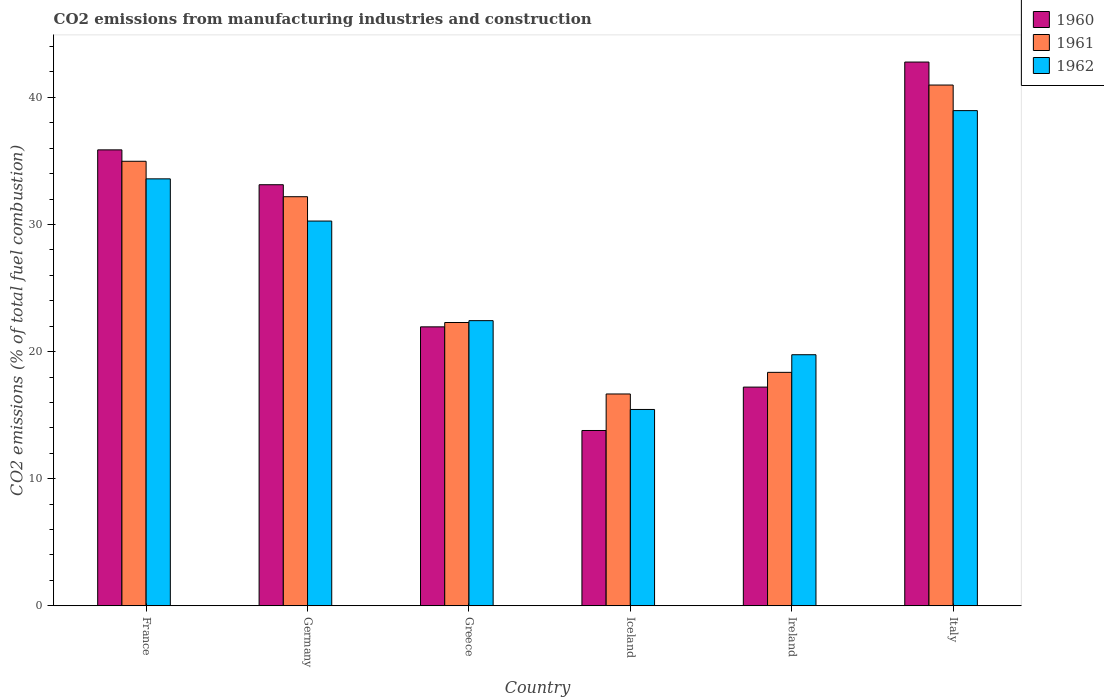How many different coloured bars are there?
Give a very brief answer. 3. How many groups of bars are there?
Your answer should be compact. 6. Are the number of bars per tick equal to the number of legend labels?
Offer a terse response. Yes. How many bars are there on the 4th tick from the right?
Your answer should be very brief. 3. What is the label of the 2nd group of bars from the left?
Your response must be concise. Germany. What is the amount of CO2 emitted in 1962 in Ireland?
Your answer should be very brief. 19.75. Across all countries, what is the maximum amount of CO2 emitted in 1960?
Make the answer very short. 42.78. Across all countries, what is the minimum amount of CO2 emitted in 1962?
Give a very brief answer. 15.45. In which country was the amount of CO2 emitted in 1960 maximum?
Your answer should be very brief. Italy. What is the total amount of CO2 emitted in 1961 in the graph?
Offer a terse response. 165.46. What is the difference between the amount of CO2 emitted in 1962 in Iceland and that in Italy?
Your answer should be very brief. -23.51. What is the difference between the amount of CO2 emitted in 1961 in Italy and the amount of CO2 emitted in 1962 in Ireland?
Your response must be concise. 21.22. What is the average amount of CO2 emitted in 1960 per country?
Your answer should be very brief. 27.46. What is the difference between the amount of CO2 emitted of/in 1961 and amount of CO2 emitted of/in 1960 in Ireland?
Offer a terse response. 1.16. What is the ratio of the amount of CO2 emitted in 1961 in Germany to that in Greece?
Provide a short and direct response. 1.44. What is the difference between the highest and the second highest amount of CO2 emitted in 1962?
Your response must be concise. -5.37. What is the difference between the highest and the lowest amount of CO2 emitted in 1962?
Offer a terse response. 23.51. In how many countries, is the amount of CO2 emitted in 1960 greater than the average amount of CO2 emitted in 1960 taken over all countries?
Offer a terse response. 3. What does the 1st bar from the right in Iceland represents?
Offer a terse response. 1962. Are all the bars in the graph horizontal?
Offer a very short reply. No. How many countries are there in the graph?
Make the answer very short. 6. What is the difference between two consecutive major ticks on the Y-axis?
Your answer should be compact. 10. Does the graph contain any zero values?
Offer a very short reply. No. How many legend labels are there?
Ensure brevity in your answer.  3. What is the title of the graph?
Give a very brief answer. CO2 emissions from manufacturing industries and construction. Does "1985" appear as one of the legend labels in the graph?
Provide a succinct answer. No. What is the label or title of the Y-axis?
Your answer should be very brief. CO2 emissions (% of total fuel combustion). What is the CO2 emissions (% of total fuel combustion) of 1960 in France?
Provide a short and direct response. 35.87. What is the CO2 emissions (% of total fuel combustion) in 1961 in France?
Your answer should be very brief. 34.98. What is the CO2 emissions (% of total fuel combustion) in 1962 in France?
Offer a very short reply. 33.59. What is the CO2 emissions (% of total fuel combustion) in 1960 in Germany?
Provide a succinct answer. 33.13. What is the CO2 emissions (% of total fuel combustion) of 1961 in Germany?
Keep it short and to the point. 32.19. What is the CO2 emissions (% of total fuel combustion) in 1962 in Germany?
Keep it short and to the point. 30.27. What is the CO2 emissions (% of total fuel combustion) in 1960 in Greece?
Keep it short and to the point. 21.95. What is the CO2 emissions (% of total fuel combustion) of 1961 in Greece?
Provide a succinct answer. 22.29. What is the CO2 emissions (% of total fuel combustion) of 1962 in Greece?
Keep it short and to the point. 22.44. What is the CO2 emissions (% of total fuel combustion) of 1960 in Iceland?
Provide a short and direct response. 13.79. What is the CO2 emissions (% of total fuel combustion) of 1961 in Iceland?
Provide a short and direct response. 16.67. What is the CO2 emissions (% of total fuel combustion) of 1962 in Iceland?
Ensure brevity in your answer.  15.45. What is the CO2 emissions (% of total fuel combustion) of 1960 in Ireland?
Make the answer very short. 17.21. What is the CO2 emissions (% of total fuel combustion) of 1961 in Ireland?
Make the answer very short. 18.37. What is the CO2 emissions (% of total fuel combustion) of 1962 in Ireland?
Offer a very short reply. 19.75. What is the CO2 emissions (% of total fuel combustion) in 1960 in Italy?
Ensure brevity in your answer.  42.78. What is the CO2 emissions (% of total fuel combustion) of 1961 in Italy?
Keep it short and to the point. 40.97. What is the CO2 emissions (% of total fuel combustion) in 1962 in Italy?
Offer a very short reply. 38.96. Across all countries, what is the maximum CO2 emissions (% of total fuel combustion) in 1960?
Make the answer very short. 42.78. Across all countries, what is the maximum CO2 emissions (% of total fuel combustion) of 1961?
Give a very brief answer. 40.97. Across all countries, what is the maximum CO2 emissions (% of total fuel combustion) in 1962?
Provide a short and direct response. 38.96. Across all countries, what is the minimum CO2 emissions (% of total fuel combustion) of 1960?
Your answer should be compact. 13.79. Across all countries, what is the minimum CO2 emissions (% of total fuel combustion) of 1961?
Provide a short and direct response. 16.67. Across all countries, what is the minimum CO2 emissions (% of total fuel combustion) of 1962?
Make the answer very short. 15.45. What is the total CO2 emissions (% of total fuel combustion) in 1960 in the graph?
Give a very brief answer. 164.73. What is the total CO2 emissions (% of total fuel combustion) of 1961 in the graph?
Provide a short and direct response. 165.46. What is the total CO2 emissions (% of total fuel combustion) in 1962 in the graph?
Provide a succinct answer. 160.46. What is the difference between the CO2 emissions (% of total fuel combustion) in 1960 in France and that in Germany?
Offer a very short reply. 2.74. What is the difference between the CO2 emissions (% of total fuel combustion) of 1961 in France and that in Germany?
Your answer should be very brief. 2.79. What is the difference between the CO2 emissions (% of total fuel combustion) in 1962 in France and that in Germany?
Your answer should be very brief. 3.32. What is the difference between the CO2 emissions (% of total fuel combustion) of 1960 in France and that in Greece?
Your response must be concise. 13.92. What is the difference between the CO2 emissions (% of total fuel combustion) in 1961 in France and that in Greece?
Your answer should be very brief. 12.69. What is the difference between the CO2 emissions (% of total fuel combustion) of 1962 in France and that in Greece?
Your answer should be compact. 11.16. What is the difference between the CO2 emissions (% of total fuel combustion) of 1960 in France and that in Iceland?
Make the answer very short. 22.08. What is the difference between the CO2 emissions (% of total fuel combustion) in 1961 in France and that in Iceland?
Make the answer very short. 18.31. What is the difference between the CO2 emissions (% of total fuel combustion) of 1962 in France and that in Iceland?
Offer a terse response. 18.14. What is the difference between the CO2 emissions (% of total fuel combustion) in 1960 in France and that in Ireland?
Offer a very short reply. 18.67. What is the difference between the CO2 emissions (% of total fuel combustion) of 1961 in France and that in Ireland?
Your answer should be very brief. 16.61. What is the difference between the CO2 emissions (% of total fuel combustion) of 1962 in France and that in Ireland?
Offer a very short reply. 13.84. What is the difference between the CO2 emissions (% of total fuel combustion) of 1960 in France and that in Italy?
Offer a terse response. -6.91. What is the difference between the CO2 emissions (% of total fuel combustion) in 1961 in France and that in Italy?
Offer a terse response. -6. What is the difference between the CO2 emissions (% of total fuel combustion) in 1962 in France and that in Italy?
Your answer should be compact. -5.37. What is the difference between the CO2 emissions (% of total fuel combustion) in 1960 in Germany and that in Greece?
Keep it short and to the point. 11.18. What is the difference between the CO2 emissions (% of total fuel combustion) of 1961 in Germany and that in Greece?
Give a very brief answer. 9.9. What is the difference between the CO2 emissions (% of total fuel combustion) of 1962 in Germany and that in Greece?
Make the answer very short. 7.84. What is the difference between the CO2 emissions (% of total fuel combustion) in 1960 in Germany and that in Iceland?
Your response must be concise. 19.34. What is the difference between the CO2 emissions (% of total fuel combustion) of 1961 in Germany and that in Iceland?
Your answer should be compact. 15.52. What is the difference between the CO2 emissions (% of total fuel combustion) of 1962 in Germany and that in Iceland?
Your response must be concise. 14.82. What is the difference between the CO2 emissions (% of total fuel combustion) in 1960 in Germany and that in Ireland?
Provide a succinct answer. 15.92. What is the difference between the CO2 emissions (% of total fuel combustion) in 1961 in Germany and that in Ireland?
Your response must be concise. 13.82. What is the difference between the CO2 emissions (% of total fuel combustion) in 1962 in Germany and that in Ireland?
Keep it short and to the point. 10.52. What is the difference between the CO2 emissions (% of total fuel combustion) in 1960 in Germany and that in Italy?
Your answer should be compact. -9.65. What is the difference between the CO2 emissions (% of total fuel combustion) of 1961 in Germany and that in Italy?
Your answer should be very brief. -8.79. What is the difference between the CO2 emissions (% of total fuel combustion) of 1962 in Germany and that in Italy?
Provide a succinct answer. -8.69. What is the difference between the CO2 emissions (% of total fuel combustion) in 1960 in Greece and that in Iceland?
Your response must be concise. 8.15. What is the difference between the CO2 emissions (% of total fuel combustion) of 1961 in Greece and that in Iceland?
Make the answer very short. 5.62. What is the difference between the CO2 emissions (% of total fuel combustion) of 1962 in Greece and that in Iceland?
Your response must be concise. 6.99. What is the difference between the CO2 emissions (% of total fuel combustion) in 1960 in Greece and that in Ireland?
Offer a terse response. 4.74. What is the difference between the CO2 emissions (% of total fuel combustion) in 1961 in Greece and that in Ireland?
Offer a terse response. 3.92. What is the difference between the CO2 emissions (% of total fuel combustion) of 1962 in Greece and that in Ireland?
Your answer should be very brief. 2.68. What is the difference between the CO2 emissions (% of total fuel combustion) in 1960 in Greece and that in Italy?
Give a very brief answer. -20.83. What is the difference between the CO2 emissions (% of total fuel combustion) of 1961 in Greece and that in Italy?
Ensure brevity in your answer.  -18.68. What is the difference between the CO2 emissions (% of total fuel combustion) of 1962 in Greece and that in Italy?
Offer a very short reply. -16.53. What is the difference between the CO2 emissions (% of total fuel combustion) of 1960 in Iceland and that in Ireland?
Make the answer very short. -3.41. What is the difference between the CO2 emissions (% of total fuel combustion) of 1961 in Iceland and that in Ireland?
Ensure brevity in your answer.  -1.7. What is the difference between the CO2 emissions (% of total fuel combustion) of 1962 in Iceland and that in Ireland?
Give a very brief answer. -4.31. What is the difference between the CO2 emissions (% of total fuel combustion) of 1960 in Iceland and that in Italy?
Offer a terse response. -28.99. What is the difference between the CO2 emissions (% of total fuel combustion) in 1961 in Iceland and that in Italy?
Offer a very short reply. -24.31. What is the difference between the CO2 emissions (% of total fuel combustion) of 1962 in Iceland and that in Italy?
Give a very brief answer. -23.51. What is the difference between the CO2 emissions (% of total fuel combustion) in 1960 in Ireland and that in Italy?
Offer a terse response. -25.57. What is the difference between the CO2 emissions (% of total fuel combustion) in 1961 in Ireland and that in Italy?
Ensure brevity in your answer.  -22.61. What is the difference between the CO2 emissions (% of total fuel combustion) of 1962 in Ireland and that in Italy?
Offer a very short reply. -19.21. What is the difference between the CO2 emissions (% of total fuel combustion) of 1960 in France and the CO2 emissions (% of total fuel combustion) of 1961 in Germany?
Make the answer very short. 3.68. What is the difference between the CO2 emissions (% of total fuel combustion) in 1960 in France and the CO2 emissions (% of total fuel combustion) in 1962 in Germany?
Make the answer very short. 5.6. What is the difference between the CO2 emissions (% of total fuel combustion) in 1961 in France and the CO2 emissions (% of total fuel combustion) in 1962 in Germany?
Make the answer very short. 4.7. What is the difference between the CO2 emissions (% of total fuel combustion) in 1960 in France and the CO2 emissions (% of total fuel combustion) in 1961 in Greece?
Offer a terse response. 13.58. What is the difference between the CO2 emissions (% of total fuel combustion) in 1960 in France and the CO2 emissions (% of total fuel combustion) in 1962 in Greece?
Your answer should be very brief. 13.44. What is the difference between the CO2 emissions (% of total fuel combustion) in 1961 in France and the CO2 emissions (% of total fuel combustion) in 1962 in Greece?
Keep it short and to the point. 12.54. What is the difference between the CO2 emissions (% of total fuel combustion) of 1960 in France and the CO2 emissions (% of total fuel combustion) of 1961 in Iceland?
Keep it short and to the point. 19.21. What is the difference between the CO2 emissions (% of total fuel combustion) in 1960 in France and the CO2 emissions (% of total fuel combustion) in 1962 in Iceland?
Your answer should be compact. 20.43. What is the difference between the CO2 emissions (% of total fuel combustion) of 1961 in France and the CO2 emissions (% of total fuel combustion) of 1962 in Iceland?
Provide a short and direct response. 19.53. What is the difference between the CO2 emissions (% of total fuel combustion) of 1960 in France and the CO2 emissions (% of total fuel combustion) of 1961 in Ireland?
Offer a terse response. 17.51. What is the difference between the CO2 emissions (% of total fuel combustion) of 1960 in France and the CO2 emissions (% of total fuel combustion) of 1962 in Ireland?
Ensure brevity in your answer.  16.12. What is the difference between the CO2 emissions (% of total fuel combustion) in 1961 in France and the CO2 emissions (% of total fuel combustion) in 1962 in Ireland?
Provide a short and direct response. 15.22. What is the difference between the CO2 emissions (% of total fuel combustion) of 1960 in France and the CO2 emissions (% of total fuel combustion) of 1961 in Italy?
Your answer should be compact. -5.1. What is the difference between the CO2 emissions (% of total fuel combustion) in 1960 in France and the CO2 emissions (% of total fuel combustion) in 1962 in Italy?
Your answer should be very brief. -3.09. What is the difference between the CO2 emissions (% of total fuel combustion) in 1961 in France and the CO2 emissions (% of total fuel combustion) in 1962 in Italy?
Your answer should be compact. -3.99. What is the difference between the CO2 emissions (% of total fuel combustion) in 1960 in Germany and the CO2 emissions (% of total fuel combustion) in 1961 in Greece?
Make the answer very short. 10.84. What is the difference between the CO2 emissions (% of total fuel combustion) in 1960 in Germany and the CO2 emissions (% of total fuel combustion) in 1962 in Greece?
Provide a succinct answer. 10.69. What is the difference between the CO2 emissions (% of total fuel combustion) in 1961 in Germany and the CO2 emissions (% of total fuel combustion) in 1962 in Greece?
Provide a succinct answer. 9.75. What is the difference between the CO2 emissions (% of total fuel combustion) in 1960 in Germany and the CO2 emissions (% of total fuel combustion) in 1961 in Iceland?
Make the answer very short. 16.46. What is the difference between the CO2 emissions (% of total fuel combustion) of 1960 in Germany and the CO2 emissions (% of total fuel combustion) of 1962 in Iceland?
Offer a very short reply. 17.68. What is the difference between the CO2 emissions (% of total fuel combustion) in 1961 in Germany and the CO2 emissions (% of total fuel combustion) in 1962 in Iceland?
Provide a succinct answer. 16.74. What is the difference between the CO2 emissions (% of total fuel combustion) of 1960 in Germany and the CO2 emissions (% of total fuel combustion) of 1961 in Ireland?
Your answer should be compact. 14.76. What is the difference between the CO2 emissions (% of total fuel combustion) of 1960 in Germany and the CO2 emissions (% of total fuel combustion) of 1962 in Ireland?
Your response must be concise. 13.38. What is the difference between the CO2 emissions (% of total fuel combustion) in 1961 in Germany and the CO2 emissions (% of total fuel combustion) in 1962 in Ireland?
Ensure brevity in your answer.  12.43. What is the difference between the CO2 emissions (% of total fuel combustion) in 1960 in Germany and the CO2 emissions (% of total fuel combustion) in 1961 in Italy?
Offer a very short reply. -7.84. What is the difference between the CO2 emissions (% of total fuel combustion) in 1960 in Germany and the CO2 emissions (% of total fuel combustion) in 1962 in Italy?
Offer a very short reply. -5.83. What is the difference between the CO2 emissions (% of total fuel combustion) in 1961 in Germany and the CO2 emissions (% of total fuel combustion) in 1962 in Italy?
Provide a succinct answer. -6.77. What is the difference between the CO2 emissions (% of total fuel combustion) in 1960 in Greece and the CO2 emissions (% of total fuel combustion) in 1961 in Iceland?
Provide a succinct answer. 5.28. What is the difference between the CO2 emissions (% of total fuel combustion) of 1960 in Greece and the CO2 emissions (% of total fuel combustion) of 1962 in Iceland?
Provide a succinct answer. 6.5. What is the difference between the CO2 emissions (% of total fuel combustion) in 1961 in Greece and the CO2 emissions (% of total fuel combustion) in 1962 in Iceland?
Offer a terse response. 6.84. What is the difference between the CO2 emissions (% of total fuel combustion) of 1960 in Greece and the CO2 emissions (% of total fuel combustion) of 1961 in Ireland?
Make the answer very short. 3.58. What is the difference between the CO2 emissions (% of total fuel combustion) in 1960 in Greece and the CO2 emissions (% of total fuel combustion) in 1962 in Ireland?
Offer a very short reply. 2.19. What is the difference between the CO2 emissions (% of total fuel combustion) in 1961 in Greece and the CO2 emissions (% of total fuel combustion) in 1962 in Ireland?
Ensure brevity in your answer.  2.54. What is the difference between the CO2 emissions (% of total fuel combustion) in 1960 in Greece and the CO2 emissions (% of total fuel combustion) in 1961 in Italy?
Your answer should be very brief. -19.03. What is the difference between the CO2 emissions (% of total fuel combustion) in 1960 in Greece and the CO2 emissions (% of total fuel combustion) in 1962 in Italy?
Provide a succinct answer. -17.01. What is the difference between the CO2 emissions (% of total fuel combustion) in 1961 in Greece and the CO2 emissions (% of total fuel combustion) in 1962 in Italy?
Provide a succinct answer. -16.67. What is the difference between the CO2 emissions (% of total fuel combustion) of 1960 in Iceland and the CO2 emissions (% of total fuel combustion) of 1961 in Ireland?
Provide a short and direct response. -4.57. What is the difference between the CO2 emissions (% of total fuel combustion) in 1960 in Iceland and the CO2 emissions (% of total fuel combustion) in 1962 in Ireland?
Your answer should be very brief. -5.96. What is the difference between the CO2 emissions (% of total fuel combustion) of 1961 in Iceland and the CO2 emissions (% of total fuel combustion) of 1962 in Ireland?
Your response must be concise. -3.09. What is the difference between the CO2 emissions (% of total fuel combustion) in 1960 in Iceland and the CO2 emissions (% of total fuel combustion) in 1961 in Italy?
Provide a short and direct response. -27.18. What is the difference between the CO2 emissions (% of total fuel combustion) of 1960 in Iceland and the CO2 emissions (% of total fuel combustion) of 1962 in Italy?
Provide a short and direct response. -25.17. What is the difference between the CO2 emissions (% of total fuel combustion) in 1961 in Iceland and the CO2 emissions (% of total fuel combustion) in 1962 in Italy?
Your response must be concise. -22.29. What is the difference between the CO2 emissions (% of total fuel combustion) in 1960 in Ireland and the CO2 emissions (% of total fuel combustion) in 1961 in Italy?
Your response must be concise. -23.77. What is the difference between the CO2 emissions (% of total fuel combustion) of 1960 in Ireland and the CO2 emissions (% of total fuel combustion) of 1962 in Italy?
Make the answer very short. -21.75. What is the difference between the CO2 emissions (% of total fuel combustion) in 1961 in Ireland and the CO2 emissions (% of total fuel combustion) in 1962 in Italy?
Your response must be concise. -20.59. What is the average CO2 emissions (% of total fuel combustion) of 1960 per country?
Your response must be concise. 27.46. What is the average CO2 emissions (% of total fuel combustion) in 1961 per country?
Your response must be concise. 27.58. What is the average CO2 emissions (% of total fuel combustion) in 1962 per country?
Make the answer very short. 26.74. What is the difference between the CO2 emissions (% of total fuel combustion) in 1960 and CO2 emissions (% of total fuel combustion) in 1961 in France?
Offer a very short reply. 0.9. What is the difference between the CO2 emissions (% of total fuel combustion) in 1960 and CO2 emissions (% of total fuel combustion) in 1962 in France?
Ensure brevity in your answer.  2.28. What is the difference between the CO2 emissions (% of total fuel combustion) of 1961 and CO2 emissions (% of total fuel combustion) of 1962 in France?
Your response must be concise. 1.38. What is the difference between the CO2 emissions (% of total fuel combustion) in 1960 and CO2 emissions (% of total fuel combustion) in 1961 in Germany?
Ensure brevity in your answer.  0.94. What is the difference between the CO2 emissions (% of total fuel combustion) in 1960 and CO2 emissions (% of total fuel combustion) in 1962 in Germany?
Offer a terse response. 2.86. What is the difference between the CO2 emissions (% of total fuel combustion) in 1961 and CO2 emissions (% of total fuel combustion) in 1962 in Germany?
Ensure brevity in your answer.  1.92. What is the difference between the CO2 emissions (% of total fuel combustion) in 1960 and CO2 emissions (% of total fuel combustion) in 1961 in Greece?
Provide a succinct answer. -0.34. What is the difference between the CO2 emissions (% of total fuel combustion) of 1960 and CO2 emissions (% of total fuel combustion) of 1962 in Greece?
Provide a short and direct response. -0.49. What is the difference between the CO2 emissions (% of total fuel combustion) of 1961 and CO2 emissions (% of total fuel combustion) of 1962 in Greece?
Offer a terse response. -0.15. What is the difference between the CO2 emissions (% of total fuel combustion) in 1960 and CO2 emissions (% of total fuel combustion) in 1961 in Iceland?
Keep it short and to the point. -2.87. What is the difference between the CO2 emissions (% of total fuel combustion) in 1960 and CO2 emissions (% of total fuel combustion) in 1962 in Iceland?
Offer a very short reply. -1.65. What is the difference between the CO2 emissions (% of total fuel combustion) of 1961 and CO2 emissions (% of total fuel combustion) of 1962 in Iceland?
Give a very brief answer. 1.22. What is the difference between the CO2 emissions (% of total fuel combustion) in 1960 and CO2 emissions (% of total fuel combustion) in 1961 in Ireland?
Your response must be concise. -1.16. What is the difference between the CO2 emissions (% of total fuel combustion) in 1960 and CO2 emissions (% of total fuel combustion) in 1962 in Ireland?
Provide a short and direct response. -2.55. What is the difference between the CO2 emissions (% of total fuel combustion) in 1961 and CO2 emissions (% of total fuel combustion) in 1962 in Ireland?
Make the answer very short. -1.39. What is the difference between the CO2 emissions (% of total fuel combustion) in 1960 and CO2 emissions (% of total fuel combustion) in 1961 in Italy?
Provide a succinct answer. 1.81. What is the difference between the CO2 emissions (% of total fuel combustion) of 1960 and CO2 emissions (% of total fuel combustion) of 1962 in Italy?
Provide a short and direct response. 3.82. What is the difference between the CO2 emissions (% of total fuel combustion) of 1961 and CO2 emissions (% of total fuel combustion) of 1962 in Italy?
Offer a terse response. 2.01. What is the ratio of the CO2 emissions (% of total fuel combustion) of 1960 in France to that in Germany?
Your answer should be compact. 1.08. What is the ratio of the CO2 emissions (% of total fuel combustion) of 1961 in France to that in Germany?
Offer a very short reply. 1.09. What is the ratio of the CO2 emissions (% of total fuel combustion) of 1962 in France to that in Germany?
Give a very brief answer. 1.11. What is the ratio of the CO2 emissions (% of total fuel combustion) of 1960 in France to that in Greece?
Offer a very short reply. 1.63. What is the ratio of the CO2 emissions (% of total fuel combustion) in 1961 in France to that in Greece?
Ensure brevity in your answer.  1.57. What is the ratio of the CO2 emissions (% of total fuel combustion) of 1962 in France to that in Greece?
Keep it short and to the point. 1.5. What is the ratio of the CO2 emissions (% of total fuel combustion) of 1960 in France to that in Iceland?
Provide a short and direct response. 2.6. What is the ratio of the CO2 emissions (% of total fuel combustion) of 1961 in France to that in Iceland?
Offer a very short reply. 2.1. What is the ratio of the CO2 emissions (% of total fuel combustion) of 1962 in France to that in Iceland?
Your response must be concise. 2.17. What is the ratio of the CO2 emissions (% of total fuel combustion) of 1960 in France to that in Ireland?
Offer a terse response. 2.08. What is the ratio of the CO2 emissions (% of total fuel combustion) in 1961 in France to that in Ireland?
Provide a short and direct response. 1.9. What is the ratio of the CO2 emissions (% of total fuel combustion) in 1962 in France to that in Ireland?
Your answer should be very brief. 1.7. What is the ratio of the CO2 emissions (% of total fuel combustion) of 1960 in France to that in Italy?
Offer a terse response. 0.84. What is the ratio of the CO2 emissions (% of total fuel combustion) of 1961 in France to that in Italy?
Ensure brevity in your answer.  0.85. What is the ratio of the CO2 emissions (% of total fuel combustion) in 1962 in France to that in Italy?
Offer a very short reply. 0.86. What is the ratio of the CO2 emissions (% of total fuel combustion) in 1960 in Germany to that in Greece?
Your response must be concise. 1.51. What is the ratio of the CO2 emissions (% of total fuel combustion) in 1961 in Germany to that in Greece?
Offer a terse response. 1.44. What is the ratio of the CO2 emissions (% of total fuel combustion) in 1962 in Germany to that in Greece?
Your answer should be very brief. 1.35. What is the ratio of the CO2 emissions (% of total fuel combustion) in 1960 in Germany to that in Iceland?
Provide a succinct answer. 2.4. What is the ratio of the CO2 emissions (% of total fuel combustion) of 1961 in Germany to that in Iceland?
Your response must be concise. 1.93. What is the ratio of the CO2 emissions (% of total fuel combustion) in 1962 in Germany to that in Iceland?
Your response must be concise. 1.96. What is the ratio of the CO2 emissions (% of total fuel combustion) of 1960 in Germany to that in Ireland?
Your response must be concise. 1.93. What is the ratio of the CO2 emissions (% of total fuel combustion) of 1961 in Germany to that in Ireland?
Give a very brief answer. 1.75. What is the ratio of the CO2 emissions (% of total fuel combustion) of 1962 in Germany to that in Ireland?
Your answer should be compact. 1.53. What is the ratio of the CO2 emissions (% of total fuel combustion) of 1960 in Germany to that in Italy?
Give a very brief answer. 0.77. What is the ratio of the CO2 emissions (% of total fuel combustion) of 1961 in Germany to that in Italy?
Keep it short and to the point. 0.79. What is the ratio of the CO2 emissions (% of total fuel combustion) of 1962 in Germany to that in Italy?
Keep it short and to the point. 0.78. What is the ratio of the CO2 emissions (% of total fuel combustion) of 1960 in Greece to that in Iceland?
Offer a very short reply. 1.59. What is the ratio of the CO2 emissions (% of total fuel combustion) of 1961 in Greece to that in Iceland?
Make the answer very short. 1.34. What is the ratio of the CO2 emissions (% of total fuel combustion) in 1962 in Greece to that in Iceland?
Provide a short and direct response. 1.45. What is the ratio of the CO2 emissions (% of total fuel combustion) in 1960 in Greece to that in Ireland?
Provide a succinct answer. 1.28. What is the ratio of the CO2 emissions (% of total fuel combustion) in 1961 in Greece to that in Ireland?
Keep it short and to the point. 1.21. What is the ratio of the CO2 emissions (% of total fuel combustion) of 1962 in Greece to that in Ireland?
Make the answer very short. 1.14. What is the ratio of the CO2 emissions (% of total fuel combustion) of 1960 in Greece to that in Italy?
Keep it short and to the point. 0.51. What is the ratio of the CO2 emissions (% of total fuel combustion) of 1961 in Greece to that in Italy?
Provide a short and direct response. 0.54. What is the ratio of the CO2 emissions (% of total fuel combustion) of 1962 in Greece to that in Italy?
Your answer should be very brief. 0.58. What is the ratio of the CO2 emissions (% of total fuel combustion) of 1960 in Iceland to that in Ireland?
Give a very brief answer. 0.8. What is the ratio of the CO2 emissions (% of total fuel combustion) of 1961 in Iceland to that in Ireland?
Provide a short and direct response. 0.91. What is the ratio of the CO2 emissions (% of total fuel combustion) in 1962 in Iceland to that in Ireland?
Your answer should be very brief. 0.78. What is the ratio of the CO2 emissions (% of total fuel combustion) of 1960 in Iceland to that in Italy?
Provide a short and direct response. 0.32. What is the ratio of the CO2 emissions (% of total fuel combustion) in 1961 in Iceland to that in Italy?
Provide a succinct answer. 0.41. What is the ratio of the CO2 emissions (% of total fuel combustion) of 1962 in Iceland to that in Italy?
Give a very brief answer. 0.4. What is the ratio of the CO2 emissions (% of total fuel combustion) of 1960 in Ireland to that in Italy?
Give a very brief answer. 0.4. What is the ratio of the CO2 emissions (% of total fuel combustion) in 1961 in Ireland to that in Italy?
Ensure brevity in your answer.  0.45. What is the ratio of the CO2 emissions (% of total fuel combustion) in 1962 in Ireland to that in Italy?
Provide a short and direct response. 0.51. What is the difference between the highest and the second highest CO2 emissions (% of total fuel combustion) of 1960?
Ensure brevity in your answer.  6.91. What is the difference between the highest and the second highest CO2 emissions (% of total fuel combustion) of 1961?
Keep it short and to the point. 6. What is the difference between the highest and the second highest CO2 emissions (% of total fuel combustion) in 1962?
Offer a very short reply. 5.37. What is the difference between the highest and the lowest CO2 emissions (% of total fuel combustion) of 1960?
Your response must be concise. 28.99. What is the difference between the highest and the lowest CO2 emissions (% of total fuel combustion) in 1961?
Offer a terse response. 24.31. What is the difference between the highest and the lowest CO2 emissions (% of total fuel combustion) of 1962?
Offer a terse response. 23.51. 